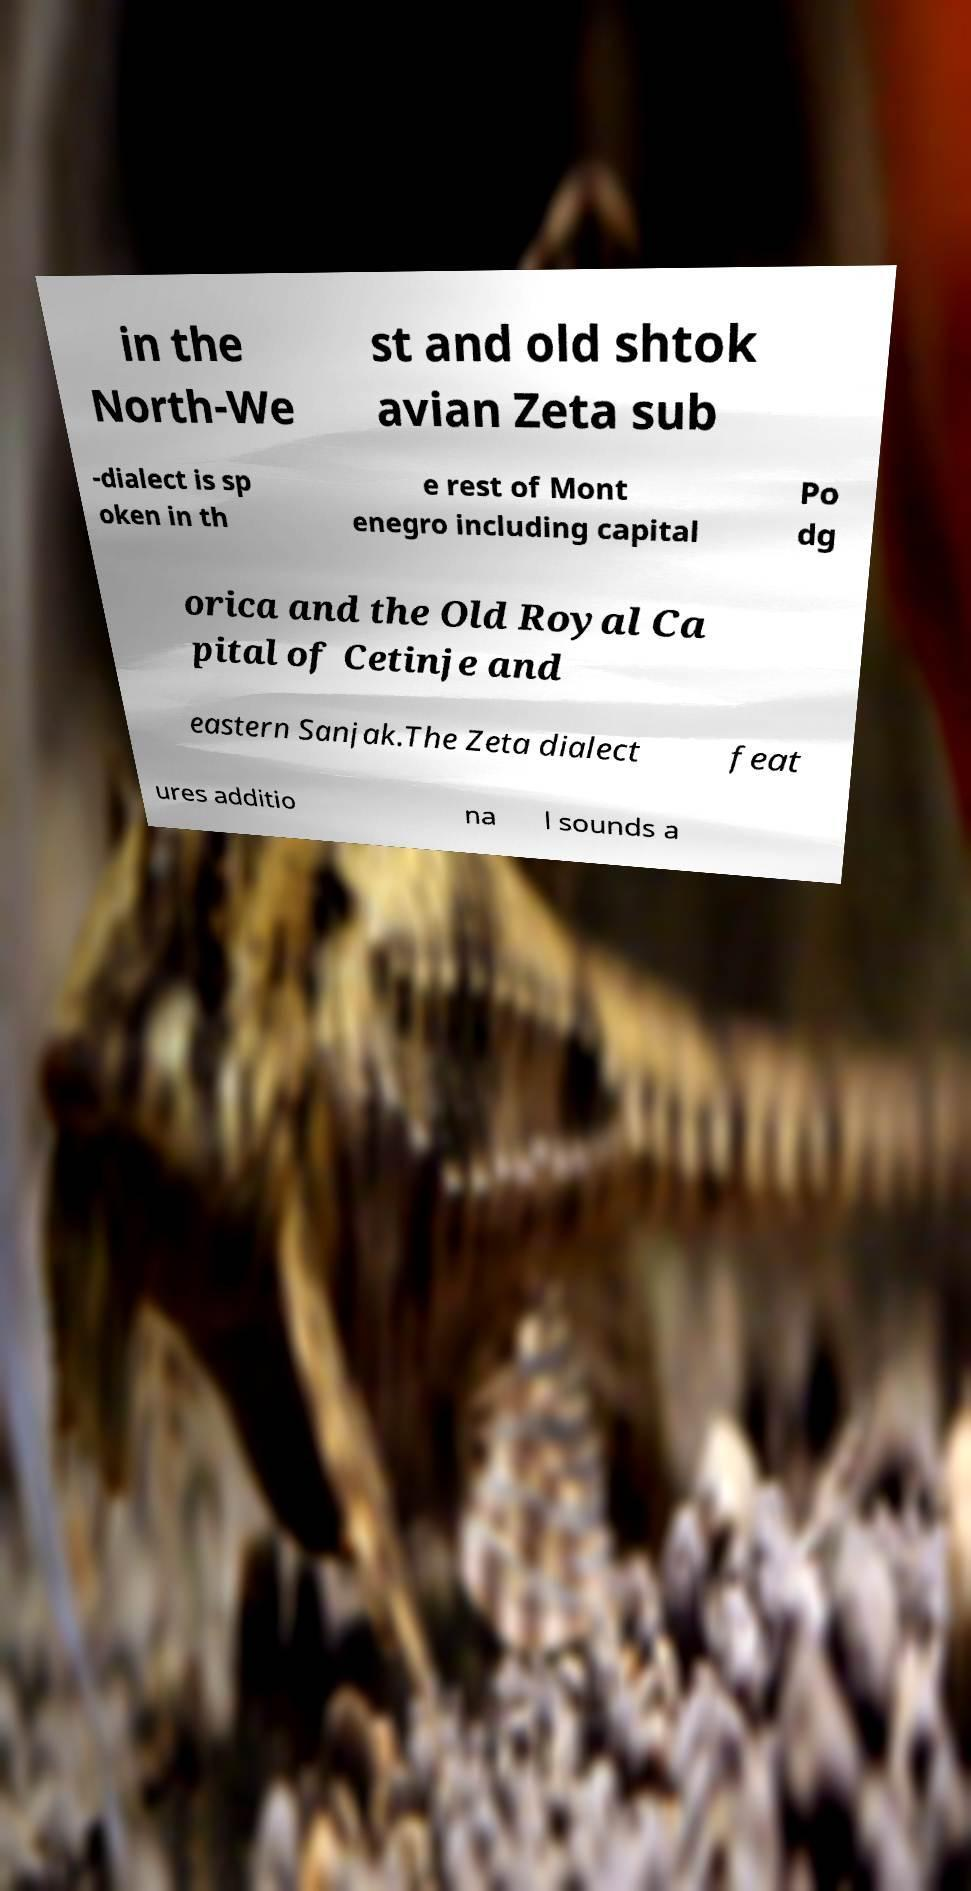Could you extract and type out the text from this image? in the North-We st and old shtok avian Zeta sub -dialect is sp oken in th e rest of Mont enegro including capital Po dg orica and the Old Royal Ca pital of Cetinje and eastern Sanjak.The Zeta dialect feat ures additio na l sounds a 